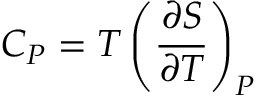<formula> <loc_0><loc_0><loc_500><loc_500>C _ { P } = T \left ( { \frac { \partial S } { \partial T } } \right ) _ { P }</formula> 